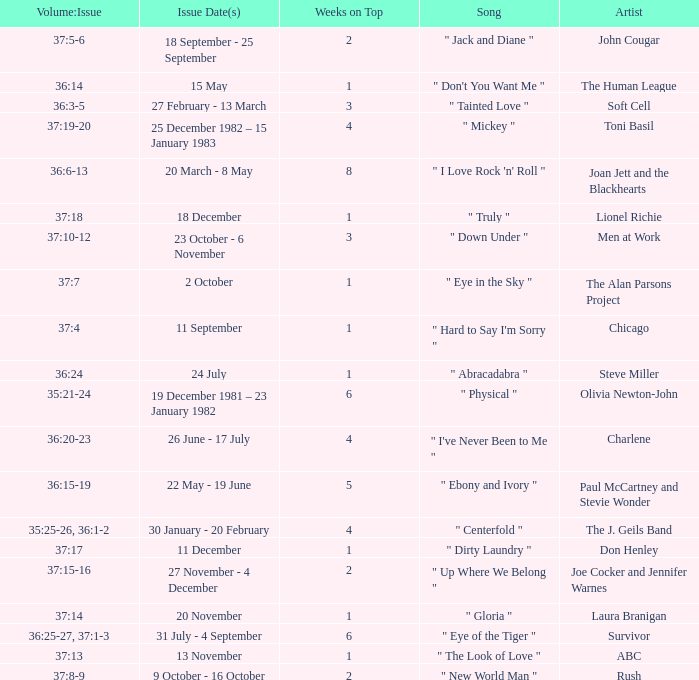Which Weeks on Top have an Issue Date(s) of 20 november? 1.0. 